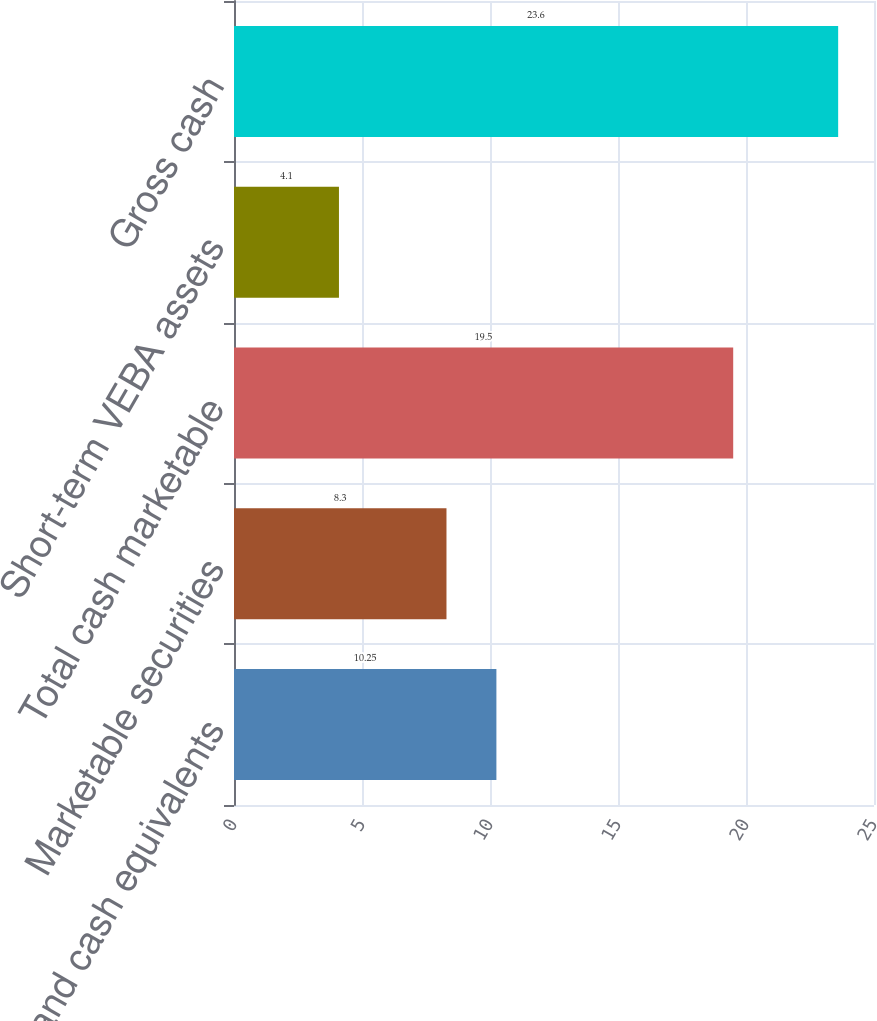<chart> <loc_0><loc_0><loc_500><loc_500><bar_chart><fcel>Cash and cash equivalents<fcel>Marketable securities<fcel>Total cash marketable<fcel>Short-term VEBA assets<fcel>Gross cash<nl><fcel>10.25<fcel>8.3<fcel>19.5<fcel>4.1<fcel>23.6<nl></chart> 